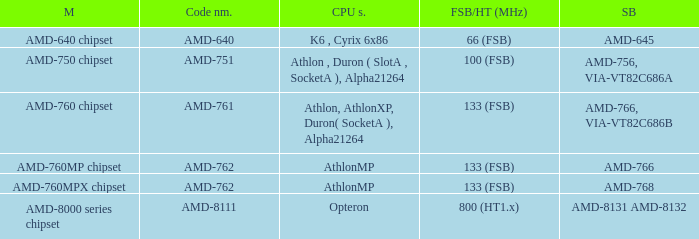What is the southbridge when the cpu compatibility was athlon, athlon xp, duron (socket a), alpha 21264? AMD-766, VIA-VT82C686B. 